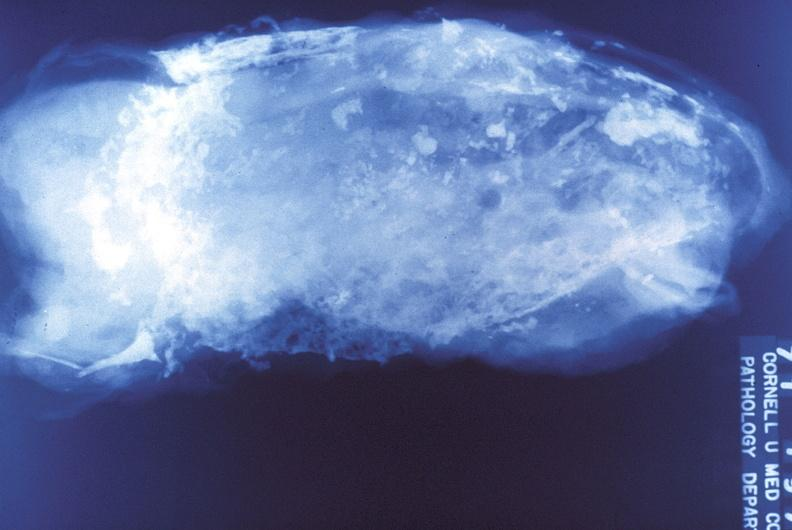s respiratory present?
Answer the question using a single word or phrase. Yes 